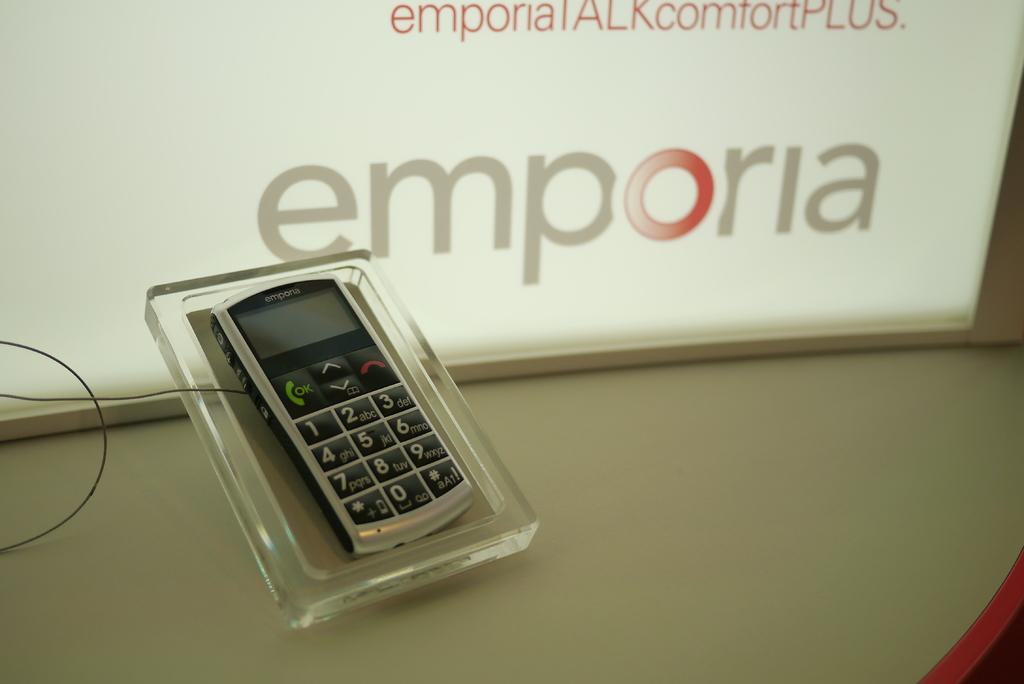Provide a one-sentence caption for the provided image. An Emporia brand phone is on display at a store. 